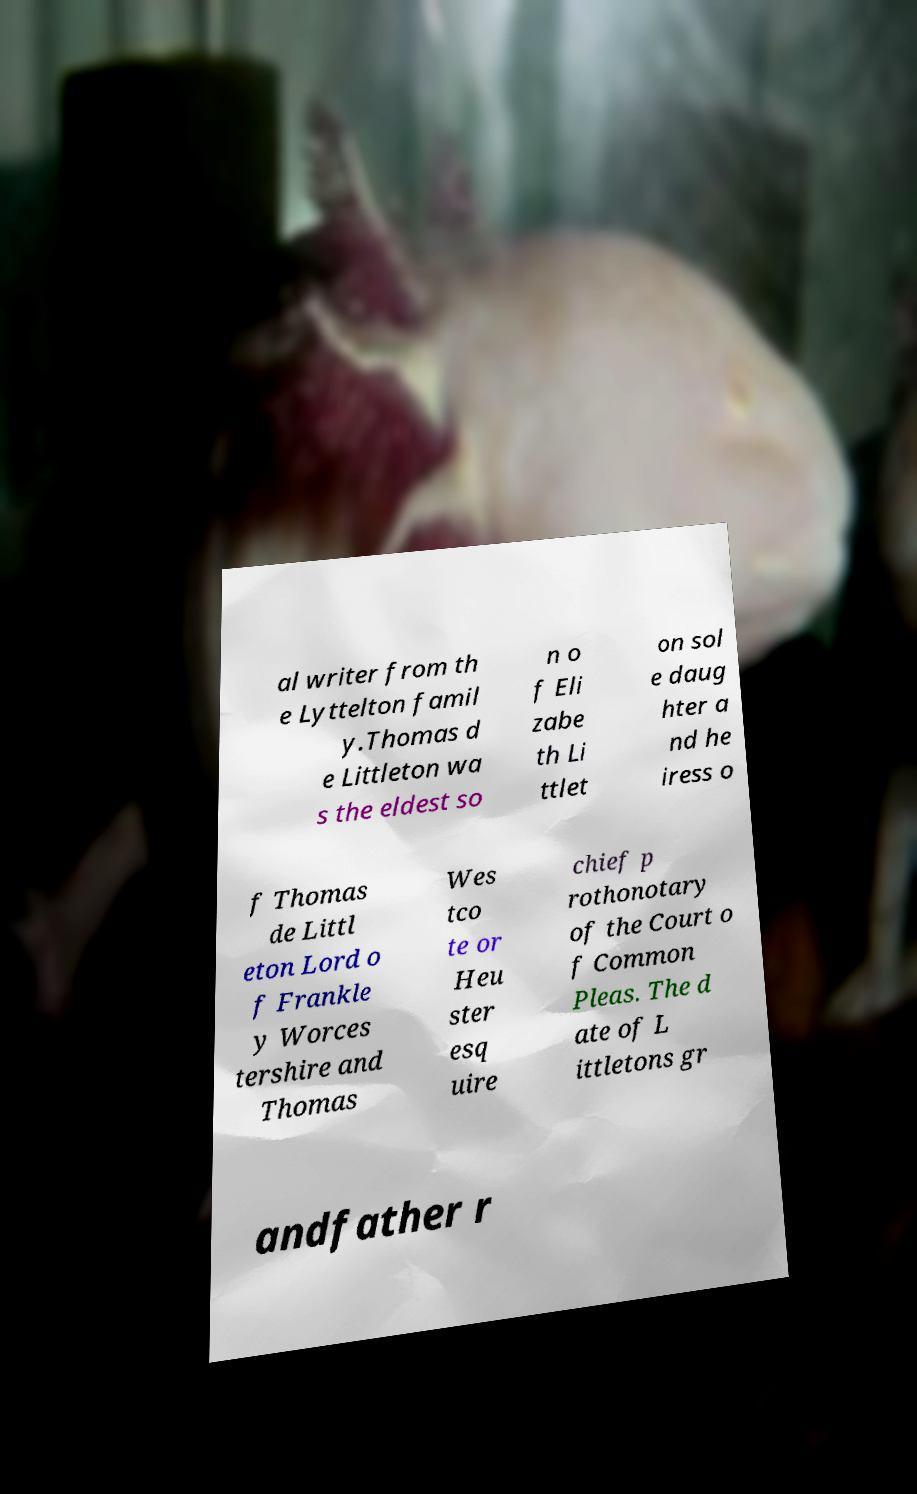For documentation purposes, I need the text within this image transcribed. Could you provide that? al writer from th e Lyttelton famil y.Thomas d e Littleton wa s the eldest so n o f Eli zabe th Li ttlet on sol e daug hter a nd he iress o f Thomas de Littl eton Lord o f Frankle y Worces tershire and Thomas Wes tco te or Heu ster esq uire chief p rothonotary of the Court o f Common Pleas. The d ate of L ittletons gr andfather r 